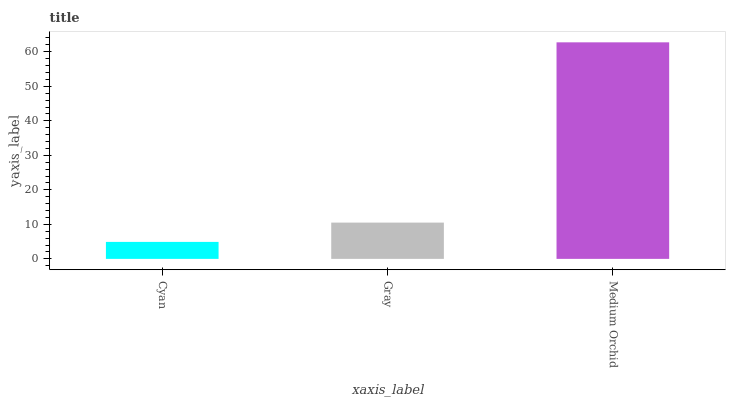Is Cyan the minimum?
Answer yes or no. Yes. Is Medium Orchid the maximum?
Answer yes or no. Yes. Is Gray the minimum?
Answer yes or no. No. Is Gray the maximum?
Answer yes or no. No. Is Gray greater than Cyan?
Answer yes or no. Yes. Is Cyan less than Gray?
Answer yes or no. Yes. Is Cyan greater than Gray?
Answer yes or no. No. Is Gray less than Cyan?
Answer yes or no. No. Is Gray the high median?
Answer yes or no. Yes. Is Gray the low median?
Answer yes or no. Yes. Is Cyan the high median?
Answer yes or no. No. Is Cyan the low median?
Answer yes or no. No. 